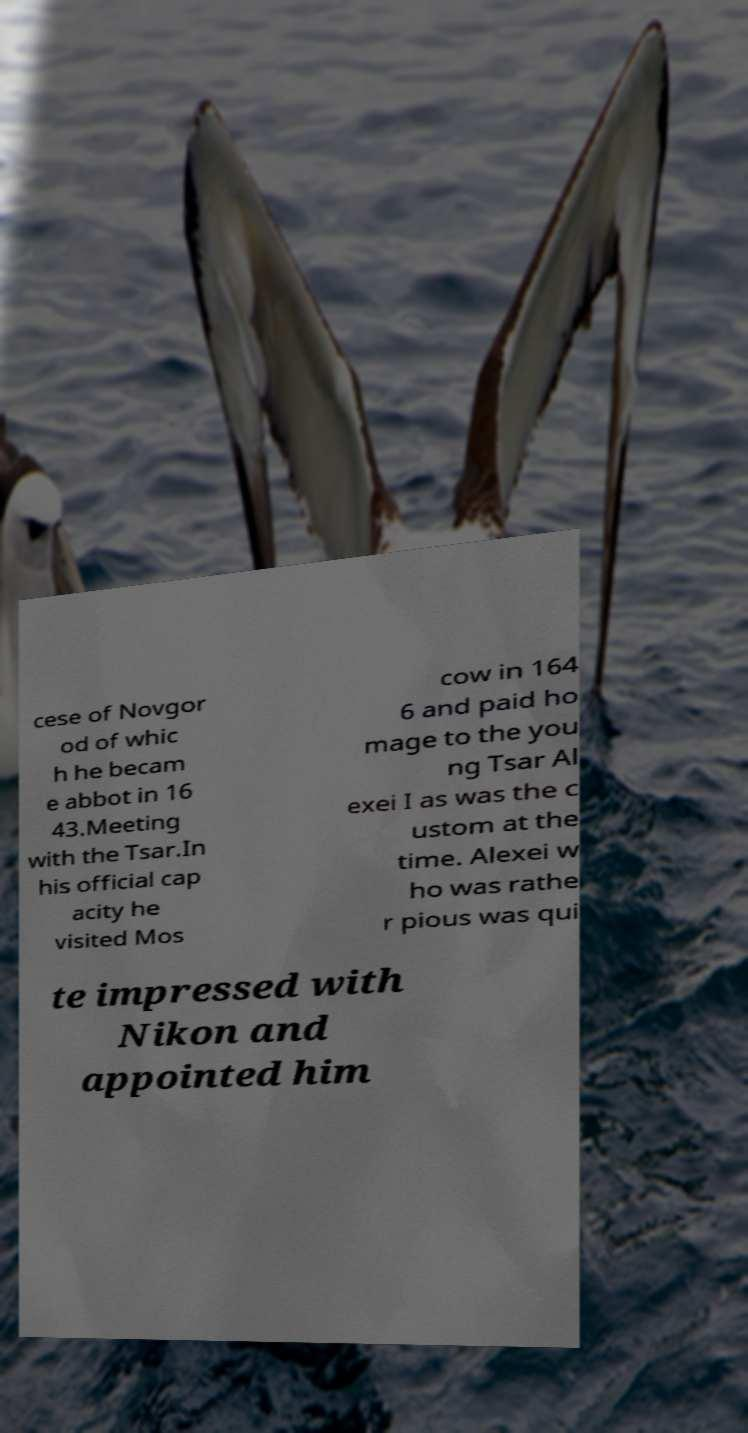Please identify and transcribe the text found in this image. cese of Novgor od of whic h he becam e abbot in 16 43.Meeting with the Tsar.In his official cap acity he visited Mos cow in 164 6 and paid ho mage to the you ng Tsar Al exei I as was the c ustom at the time. Alexei w ho was rathe r pious was qui te impressed with Nikon and appointed him 